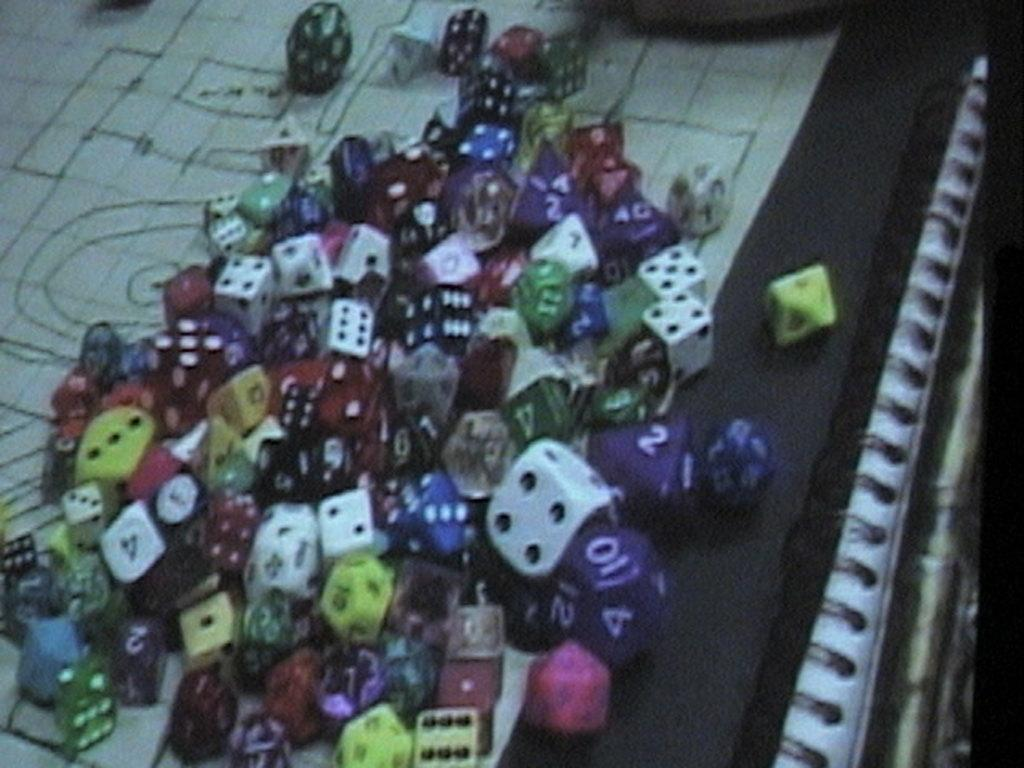What objects are present in the image? There are dices in the image. Can you describe the dices in more detail? The dices are in different colors. What surface are the dices placed on? The dices are on a surface that looks like a board. What type of agreement can be seen between the gold tooth and the dices in the image? There is no gold tooth or any agreement present in the image; it only features dices on a board-like surface. 